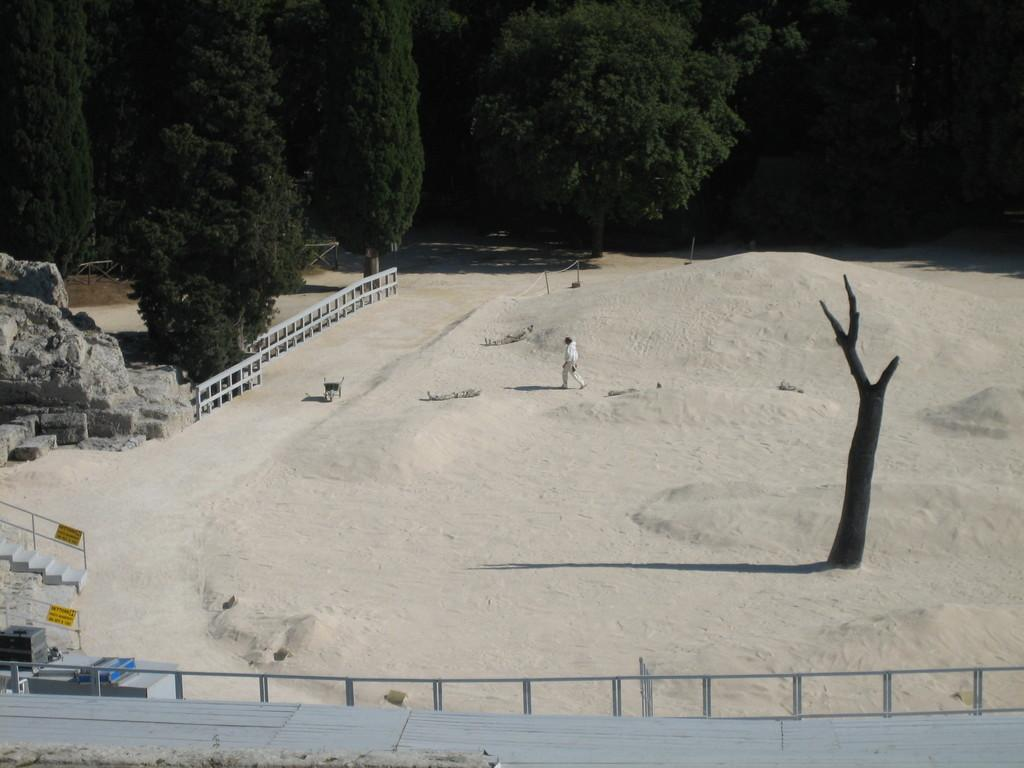What is the person in the image doing? The person is walking in the image. Where is the person walking? The person is on a playground. What can be seen in the background of the image? There are trees in the background of the image. What is located in the middle of the image? There is a trunk in the middle of the image. What architectural features are present in the front of the image? There is a fence and steps in the front of the image. What time of day is it in the image, and what color crayon is the person using to draw on the trunk? The time of day is not mentioned in the image, and there is no crayon or drawing activity present. 